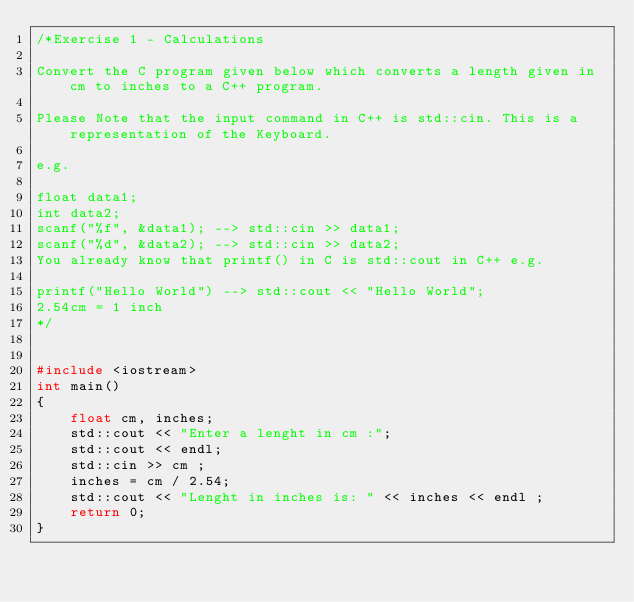<code> <loc_0><loc_0><loc_500><loc_500><_C++_>/*Exercise 1 - Calculations

Convert the C program given below which converts a length given in cm to inches to a C++ program.

Please Note that the input command in C++ is std::cin. This is a representation of the Keyboard.

e.g.

float data1;
int data2;
scanf("%f", &data1); --> std::cin >> data1;
scanf("%d", &data2); --> std::cin >> data2; 
You already know that printf() in C is std::cout in C++ e.g.

printf("Hello World") --> std::cout << "Hello World";
2.54cm = 1 inch
*/


#include <iostream>
int main() 
{
    float cm, inches;
    std::cout << "Enter a lenght in cm :";
    std::cout << endl;
    std::cin >> cm ;
    inches = cm / 2.54;
    std::cout << "Lenght in inches is: " << inches << endl ;
    return 0;
}  
</code> 